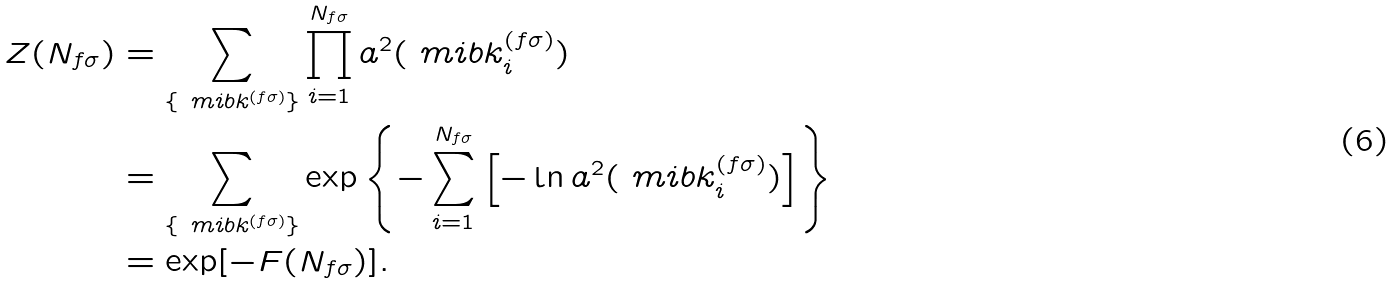Convert formula to latex. <formula><loc_0><loc_0><loc_500><loc_500>Z ( N _ { f \sigma } ) & = \sum _ { \{ \ m i b { k } ^ { ( f \sigma ) } \} } \prod ^ { N _ { f \sigma } } _ { i = 1 } a ^ { 2 } ( \ m i b { k } ^ { ( f \sigma ) } _ { i } ) \\ & = \sum _ { \{ \ m i b { k } ^ { ( f \sigma ) } \} } \exp \left \{ - \sum ^ { N _ { f \sigma } } _ { i = 1 } \left [ - \ln a ^ { 2 } ( \ m i b { k } ^ { ( f \sigma ) } _ { i } ) \right ] \right \} \\ & = \exp [ - F ( N _ { f \sigma } ) ] .</formula> 